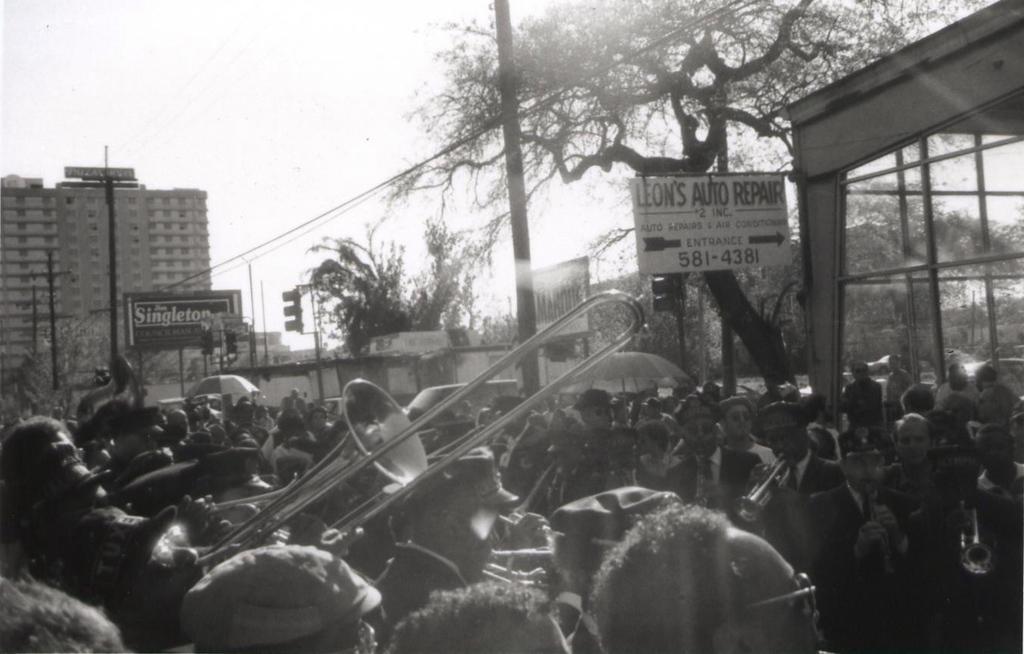Please provide a concise description of this image. This is a black and white image. I can see groups of people standing. Among them few people are playing the musical instruments. This looks like an address board. I can see the buildings. These are the trees. This looks like a hoarding. Here is an umbrella. I can see a traffic signal, which is attached to a pole. I think this is a vehicle. On the right side of the image, I think this is a glass door. 